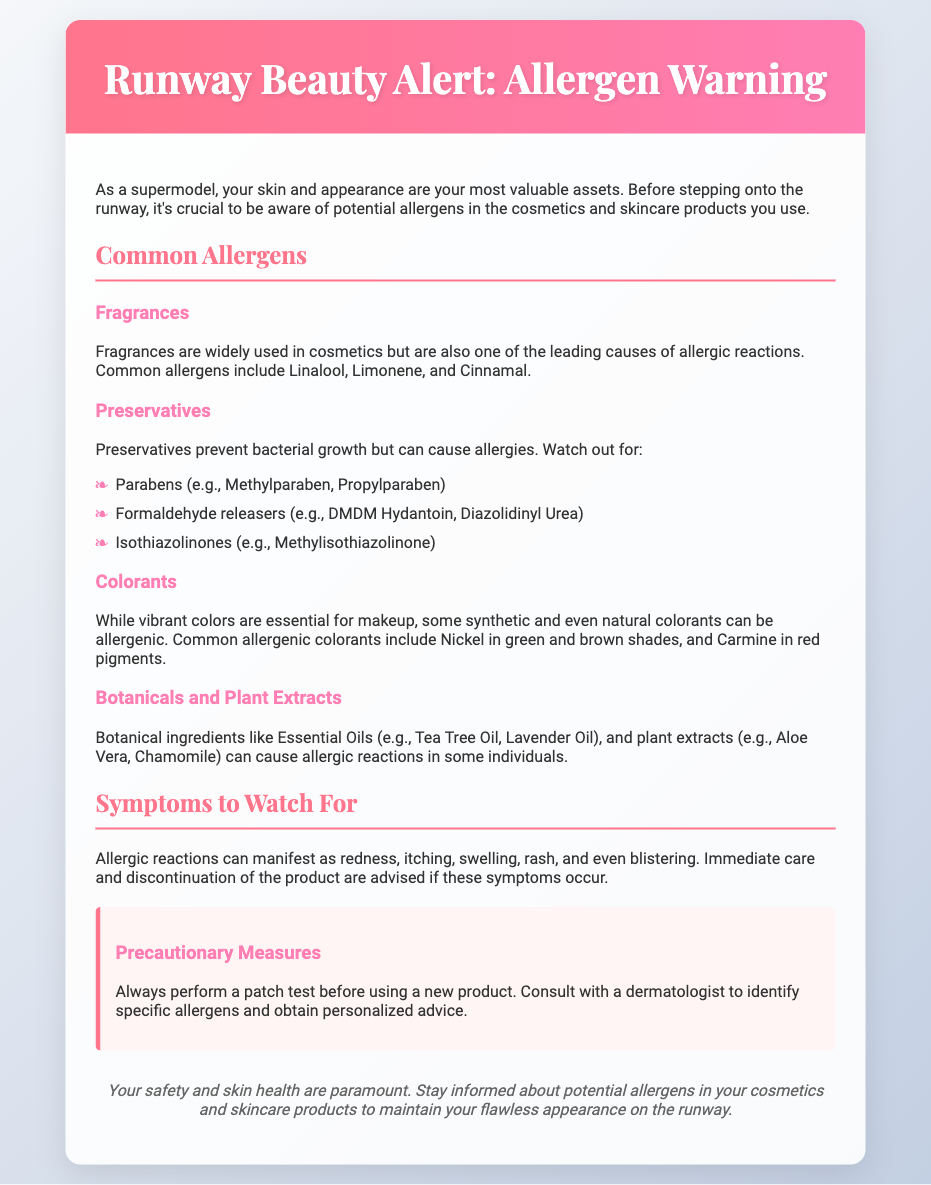What is the title of the document? The title of the document is prominently displayed in the header section.
Answer: Runway Beauty Alert: Allergen Warning What are the leading causes of allergic reactions in cosmetics? The document lists allergens that frequently lead to allergies in cosmetics.
Answer: Fragrances Name a common preservative that can cause allergies. The document explicitly mentions several preservatives known to cause allergic reactions.
Answer: Parabens What should you do if you notice symptoms of an allergic reaction? The document advises certain actions to take if allergic symptoms appear.
Answer: Discontinue the product Which botanical ingredient is mentioned as a potential allergen? The document provides examples of botanicals that can trigger allergies in some individuals.
Answer: Essential Oils How many common allergens are listed under preservatives? The document categorizes different types of allergens, including how many are in the preservatives section.
Answer: Three What precautionary measure is recommended in the document? The document emphasizes actions you should take before using new products.
Answer: Perform a patch test What symptoms are mentioned as signs of allergic reactions? The document lists various symptoms that may indicate an allergic reaction is occurring.
Answer: Redness, itching, swelling, rash, blistering Which colorant is associated with allergic reactions in red pigments? The document specifies a colorant that is known to cause allergies in a particular pigment group.
Answer: Carmine 